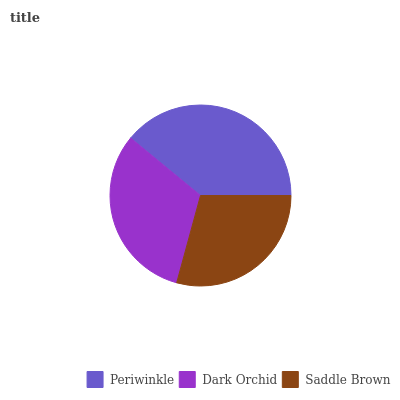Is Saddle Brown the minimum?
Answer yes or no. Yes. Is Periwinkle the maximum?
Answer yes or no. Yes. Is Dark Orchid the minimum?
Answer yes or no. No. Is Dark Orchid the maximum?
Answer yes or no. No. Is Periwinkle greater than Dark Orchid?
Answer yes or no. Yes. Is Dark Orchid less than Periwinkle?
Answer yes or no. Yes. Is Dark Orchid greater than Periwinkle?
Answer yes or no. No. Is Periwinkle less than Dark Orchid?
Answer yes or no. No. Is Dark Orchid the high median?
Answer yes or no. Yes. Is Dark Orchid the low median?
Answer yes or no. Yes. Is Saddle Brown the high median?
Answer yes or no. No. Is Periwinkle the low median?
Answer yes or no. No. 